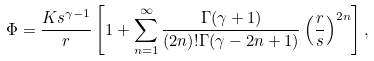Convert formula to latex. <formula><loc_0><loc_0><loc_500><loc_500>\Phi = \frac { K s ^ { \gamma - 1 } } r \left [ 1 + \sum _ { n = 1 } ^ { \infty } \frac { \Gamma ( \gamma + 1 ) } { ( 2 n ) ! \Gamma ( \gamma - 2 n + 1 ) } \left ( \frac { r } { s } \right ) ^ { 2 n } \right ] ,</formula> 